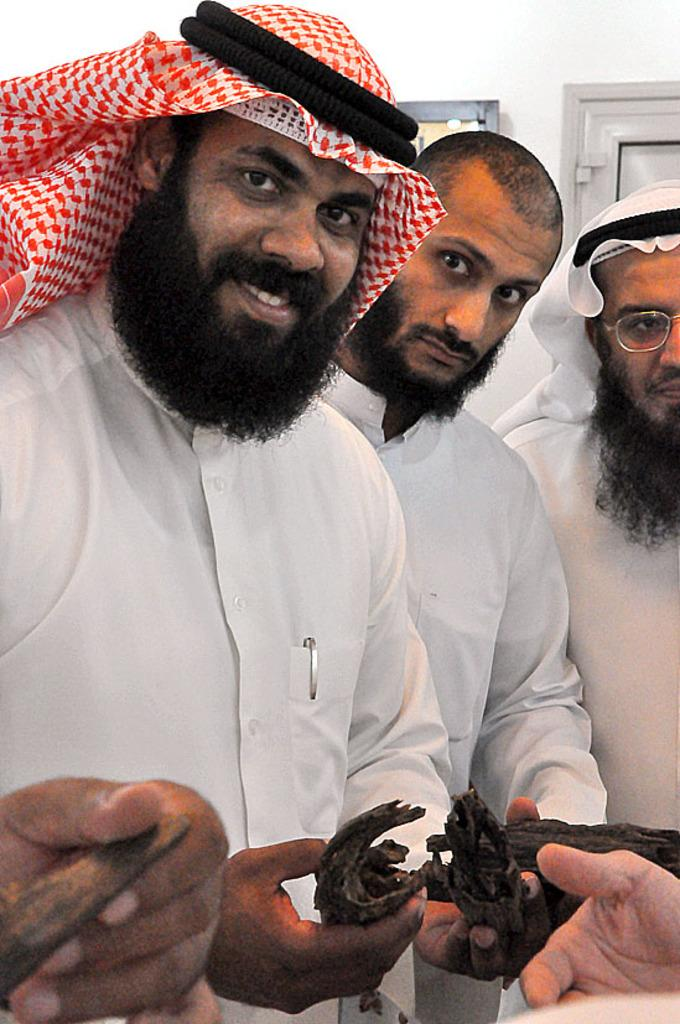How many people are in the image? There are people in the image, but the exact number is not specified. What are the people doing in the image? The people are standing in the image. What type of weather can be seen through the window in the image? There is no window present in the image, so it is not possible to determine the weather from the image. 